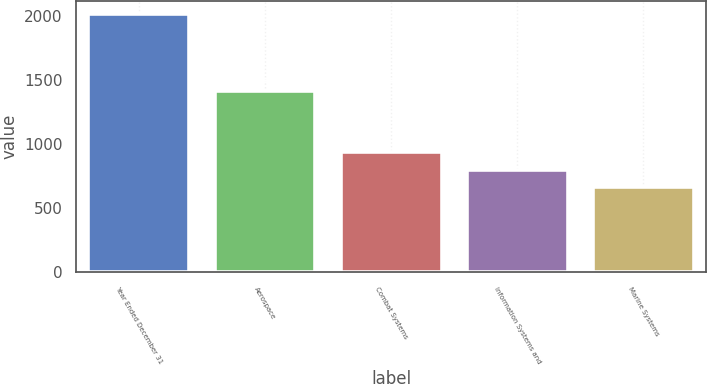<chart> <loc_0><loc_0><loc_500><loc_500><bar_chart><fcel>Year Ended December 31<fcel>Aerospace<fcel>Combat Systems<fcel>Information Systems and<fcel>Marine Systems<nl><fcel>2013<fcel>1416<fcel>935.4<fcel>800.7<fcel>666<nl></chart> 